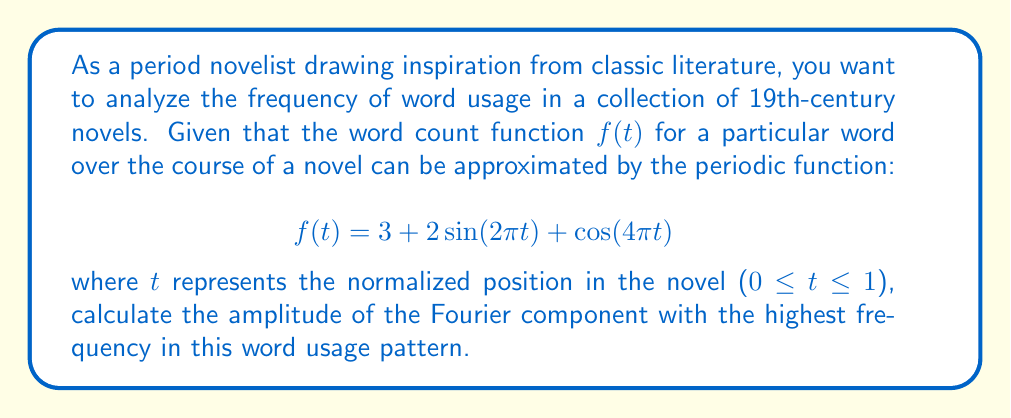Teach me how to tackle this problem. To solve this problem, we'll follow these steps:

1) First, recall that the Fourier transform decomposes a function into its frequency components. In this case, our function is already expressed as a sum of sinusoidal functions.

2) The given function is:
   $$f(t) = 3 + 2\sin(2\pi t) + \cos(4\pi t)$$

3) We can identify three components:
   - A constant term: 3
   - A sinusoidal term with frequency $2\pi$: $2\sin(2\pi t)$
   - A cosine term with frequency $4\pi$: $\cos(4\pi t)$

4) The highest frequency component is the one with $4\pi$, which is $\cos(4\pi t)$.

5) The amplitude of a cosine function $a\cos(bt)$ is given by $|a|$.

6) In this case, the amplitude of the highest frequency component is $|1| = 1$.

Therefore, the amplitude of the Fourier component with the highest frequency is 1.
Answer: 1 